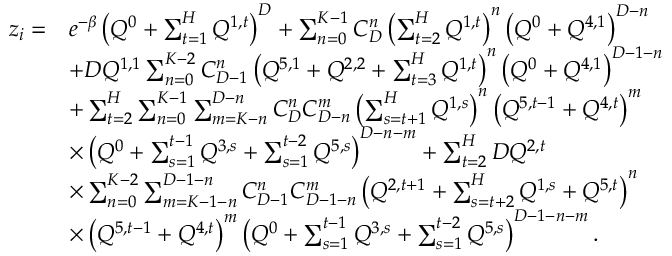Convert formula to latex. <formula><loc_0><loc_0><loc_500><loc_500>\begin{array} { r l } { z _ { i } = } & { e ^ { - \beta } \left ( Q ^ { 0 } + \sum _ { t = 1 } ^ { H } Q ^ { 1 , t } \right ) ^ { D } + \sum _ { n = 0 } ^ { K - 1 } C _ { D } ^ { n } \left ( \sum _ { t = 2 } ^ { H } Q ^ { 1 , t } \right ) ^ { n } \left ( Q ^ { 0 } + Q ^ { 4 , 1 } \right ) ^ { D - n } } \\ & { + D Q ^ { 1 , 1 } \sum _ { n = 0 } ^ { K - 2 } C _ { D - 1 } ^ { n } \left ( Q ^ { 5 , 1 } + Q ^ { 2 , 2 } + \sum _ { t = 3 } ^ { H } Q ^ { 1 , t } \right ) ^ { n } \left ( Q ^ { 0 } + Q ^ { 4 , 1 } \right ) ^ { D - 1 - n } } \\ & { + \sum _ { t = 2 } ^ { H } \sum _ { n = 0 } ^ { K - 1 } \sum _ { m = K - n } ^ { D - n } C _ { D } ^ { n } C _ { D - n } ^ { m } \left ( \sum _ { s = t + 1 } ^ { H } Q ^ { 1 , s } \right ) ^ { n } \left ( Q ^ { 5 , t - 1 } + Q ^ { 4 , t } \right ) ^ { m } } \\ & { \times \left ( Q ^ { 0 } + \sum _ { s = 1 } ^ { t - 1 } Q ^ { 3 , s } + \sum _ { s = 1 } ^ { t - 2 } Q ^ { 5 , s } \right ) ^ { D - n - m } + \sum _ { t = 2 } ^ { H } D Q ^ { 2 , t } } \\ & { \times \sum _ { n = 0 } ^ { K - 2 } \sum _ { m = K - 1 - n } ^ { D - 1 - n } C _ { D - 1 } ^ { n } C _ { D - 1 - n } ^ { m } \left ( Q ^ { 2 , t + 1 } + \sum _ { s = t + 2 } ^ { H } Q ^ { 1 , s } + Q ^ { 5 , t } \right ) ^ { n } } \\ & { \times \left ( Q ^ { 5 , t - 1 } + Q ^ { 4 , t } \right ) ^ { m } \left ( Q ^ { 0 } + \sum _ { s = 1 } ^ { t - 1 } Q ^ { 3 , s } + \sum _ { s = 1 } ^ { t - 2 } Q ^ { 5 , s } \right ) ^ { D - 1 - n - m } . } \end{array}</formula> 